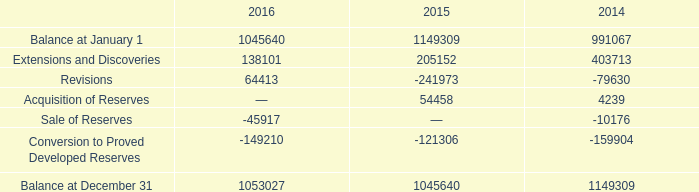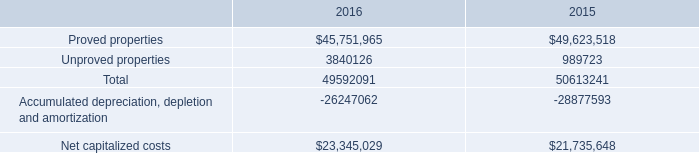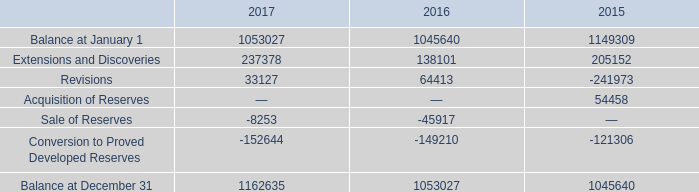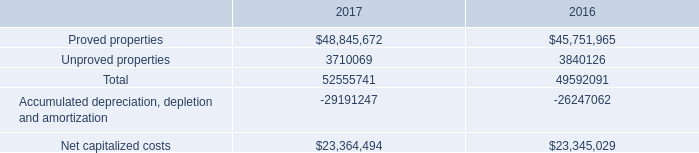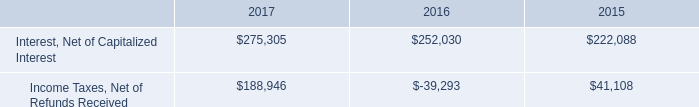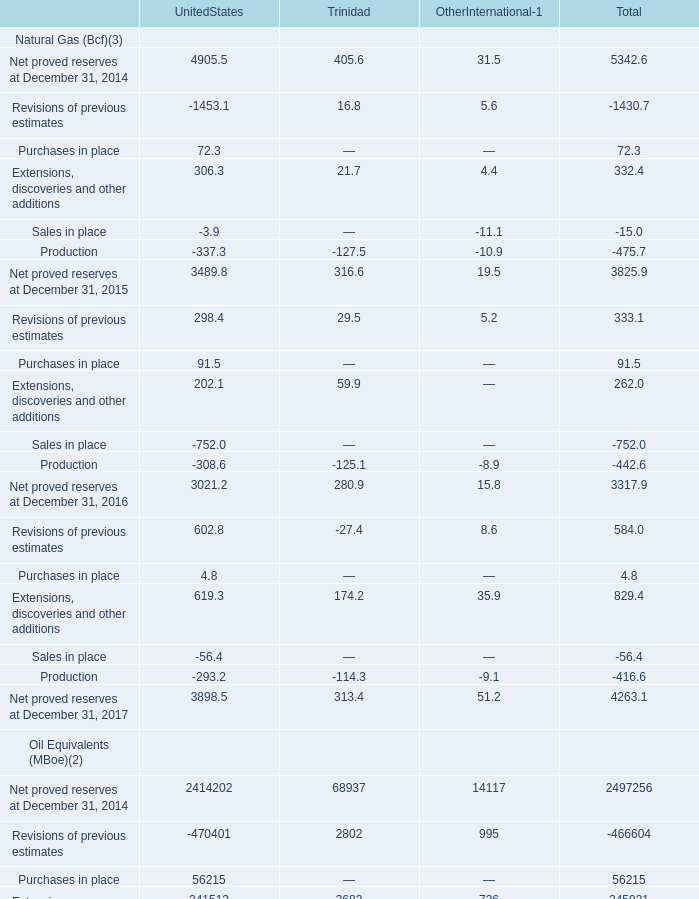What is the average amount of Sale of Reserves of 2014, and Income Taxes, Net of Refunds Received of 2015 ? 
Computations: ((10176.0 + 41108.0) / 2)
Answer: 25642.0. 